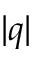Convert formula to latex. <formula><loc_0><loc_0><loc_500><loc_500>| q |</formula> 